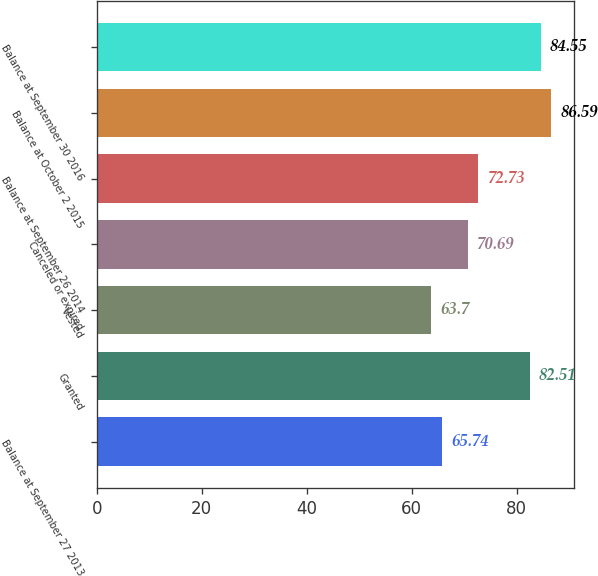<chart> <loc_0><loc_0><loc_500><loc_500><bar_chart><fcel>Balance at September 27 2013<fcel>Granted<fcel>Vested<fcel>Canceled or expired<fcel>Balance at September 26 2014<fcel>Balance at October 2 2015<fcel>Balance at September 30 2016<nl><fcel>65.74<fcel>82.51<fcel>63.7<fcel>70.69<fcel>72.73<fcel>86.59<fcel>84.55<nl></chart> 